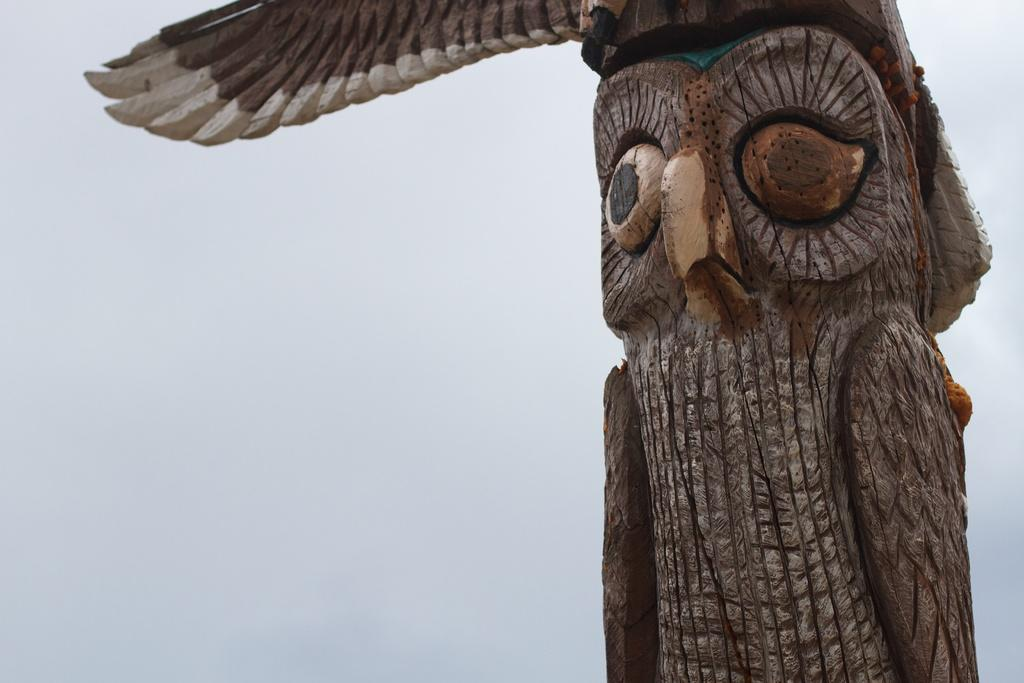What type of animal is depicted in the sculpture in the image? There is a sculpture of a hawk in the image. Can you describe the sculpture in more detail? Unfortunately, the provided facts do not offer any additional details about the sculpture. How many pizzas are being served on the lumber in the image? There is no mention of pizzas or lumber in the image, so this question cannot be answered. 